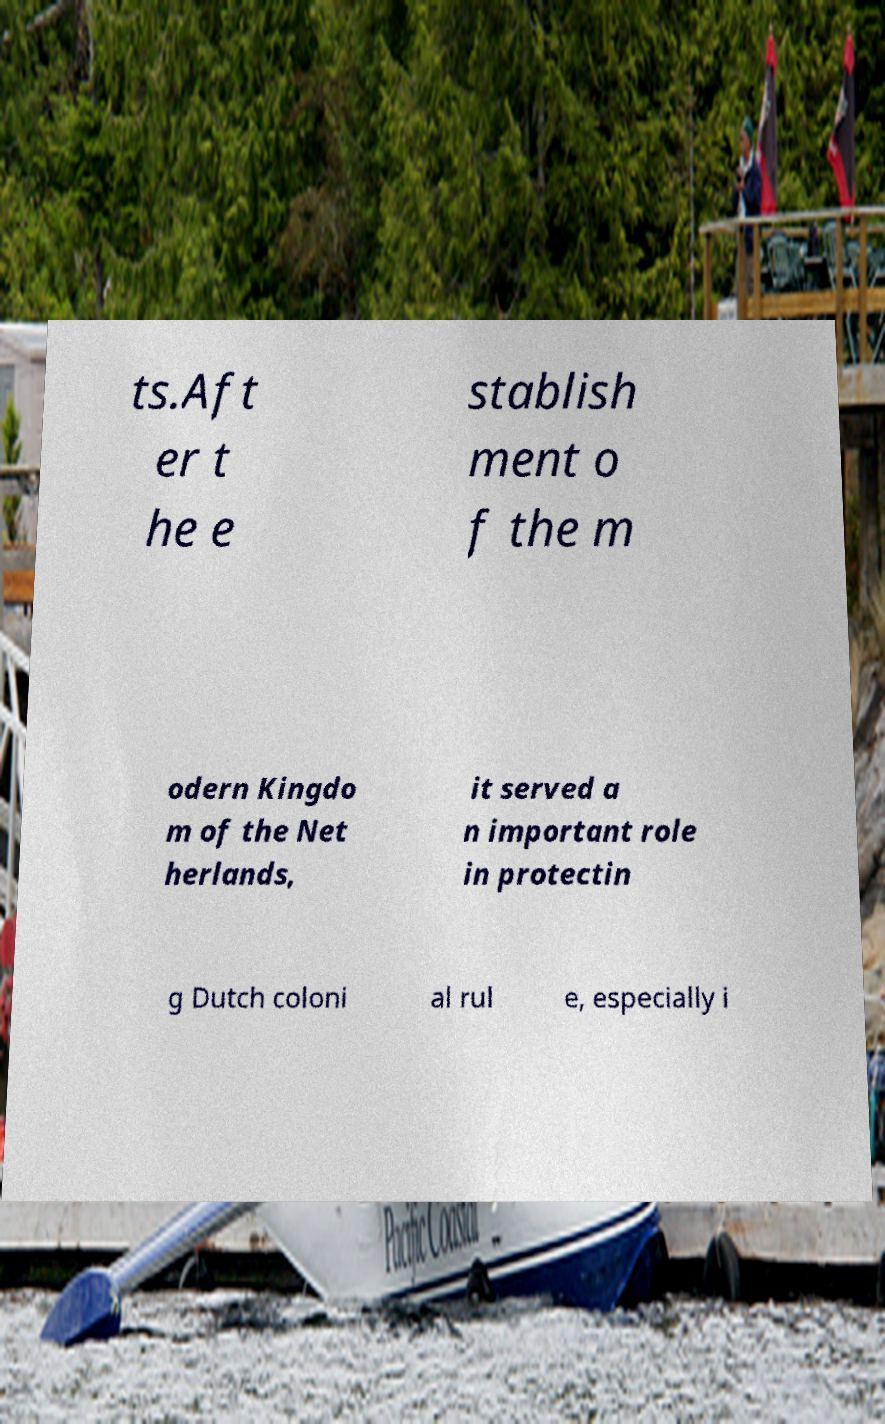For documentation purposes, I need the text within this image transcribed. Could you provide that? ts.Aft er t he e stablish ment o f the m odern Kingdo m of the Net herlands, it served a n important role in protectin g Dutch coloni al rul e, especially i 